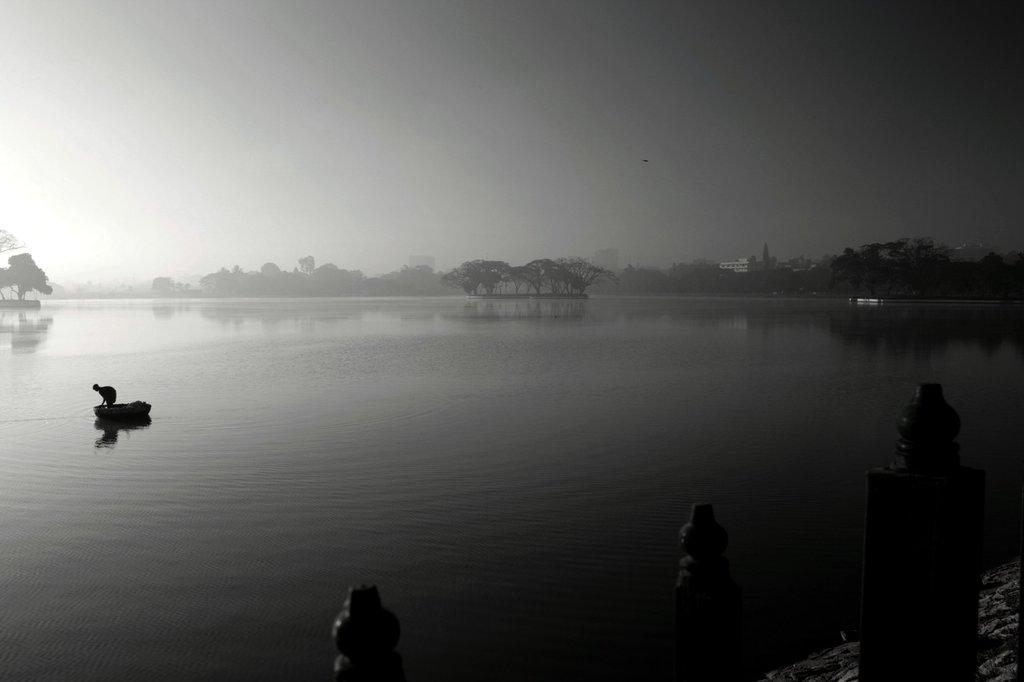Can you describe this image briefly? In this image I can see the lake and in the lake I can see a boat and person ,at the bottom I can see there are some poles visible. In the middle there are some trees visible, at the top I can see the sky. 